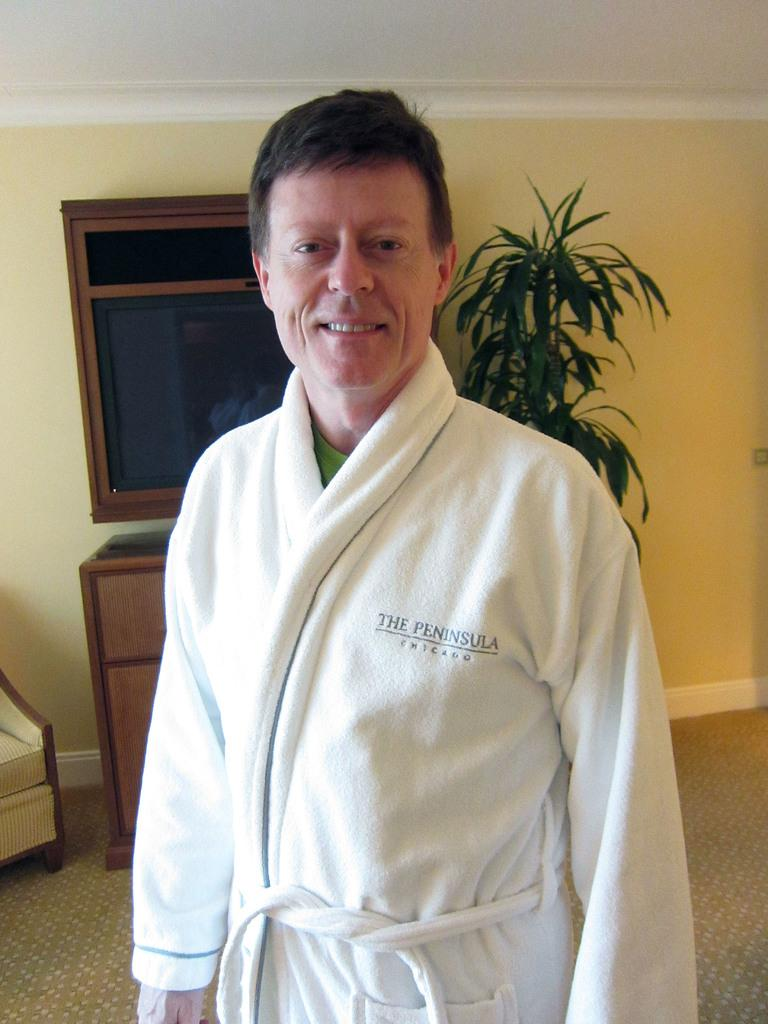What is the man in the image wearing? The man is wearing a white robe. What can be seen in the image besides the man? There is a plant and a cabinet in the image. What color is the wall behind the man? The wall behind the man is yellow. What type of bag is the man carrying in the image? There is no bag present in the image. What is the man copying in the image? There is no indication that the man is copying anything in the image. 